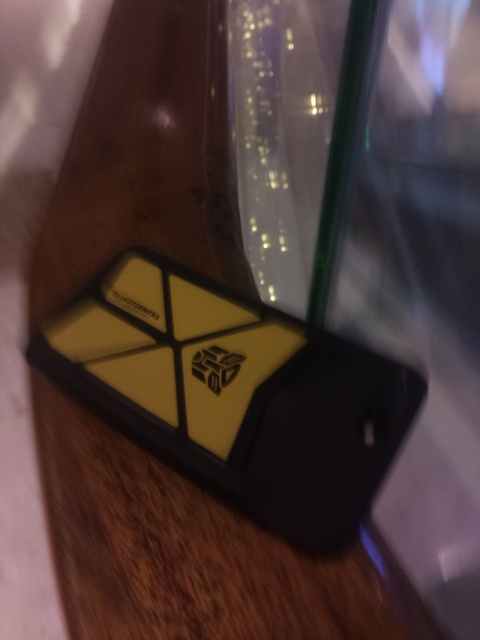How is the tilt of this image?
A. significantly
B. slightly
C. perfectly
D. completely The image has a slight tilt to it; it's not perfectly aligned with the frame of the photo. Objects within the picture, like the phone, are seen at an angle which suggests that the camera was not held perfectly level when the picture was taken. Therefore, option B ('slightly') is the most accurate choice. 